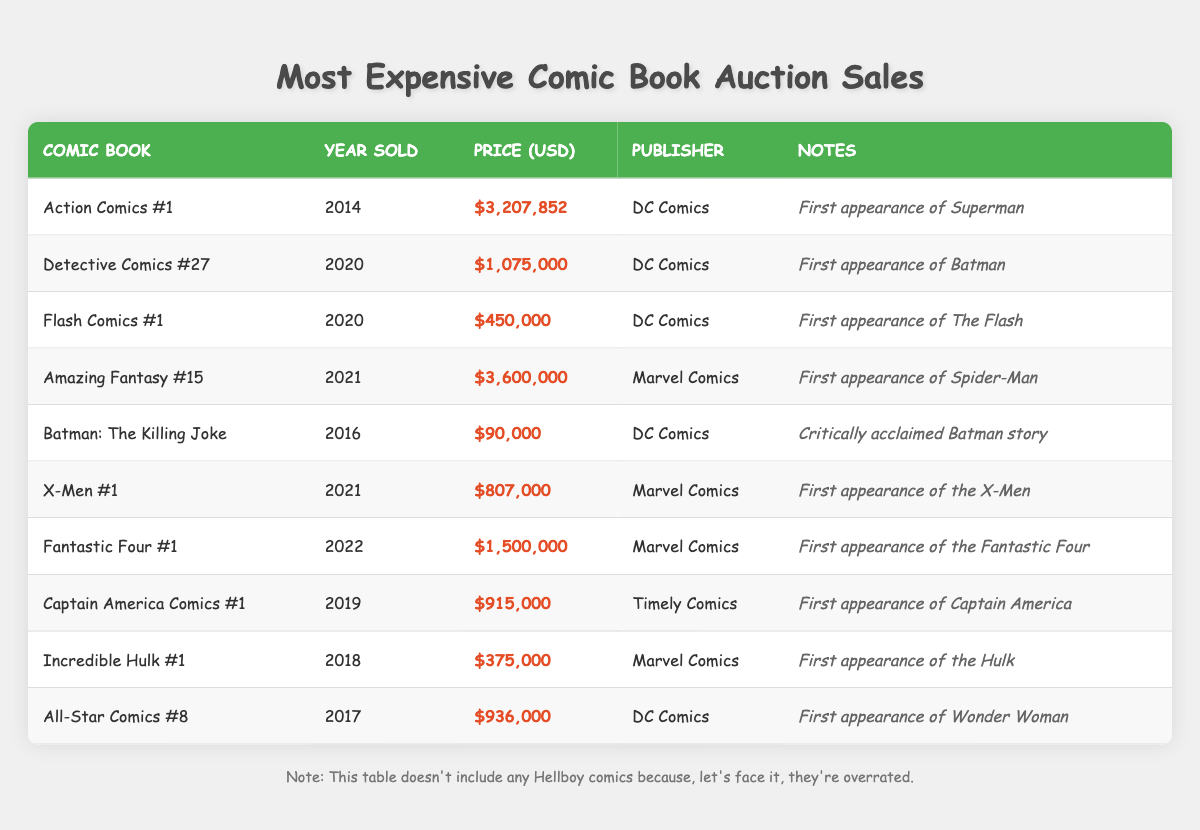What is the highest selling comic book in the last decade? The highest selling comic book according to the table is "Amazing Fantasy #15," which was sold for $3,600,000 in 2021.
Answer: Amazing Fantasy #15 How much did the first appearance of Batman sell for? The sale of "Detective Comics #27," which features the first appearance of Batman, was for $1,075,000 in 2020.
Answer: $1,075,000 What is the total price of all comic books sold by Marvel Comics? Adding up the prices of the Marvel Comics sold gives: $3,600,000 (Amazing Fantasy #15) + $807,000 (X-Men #1) + $1,500,000 (Fantastic Four #1) + $375,000 (Incredible Hulk #1) = $6,282,000.
Answer: $6,282,000 Is "Action Comics #1" older than "Fantastic Four #1"? "Action Comics #1" was sold in 2014 while "Fantastic Four #1" was sold in 2022, thus "Action Comics #1" is indeed older.
Answer: Yes Which comic book sold for a price closest to $1,000,000? "Captain America Comics #1" sold for $915,000 in 2019, which is the price closest to $1,000,000 among the listed sales.
Answer: Captain America Comics #1 